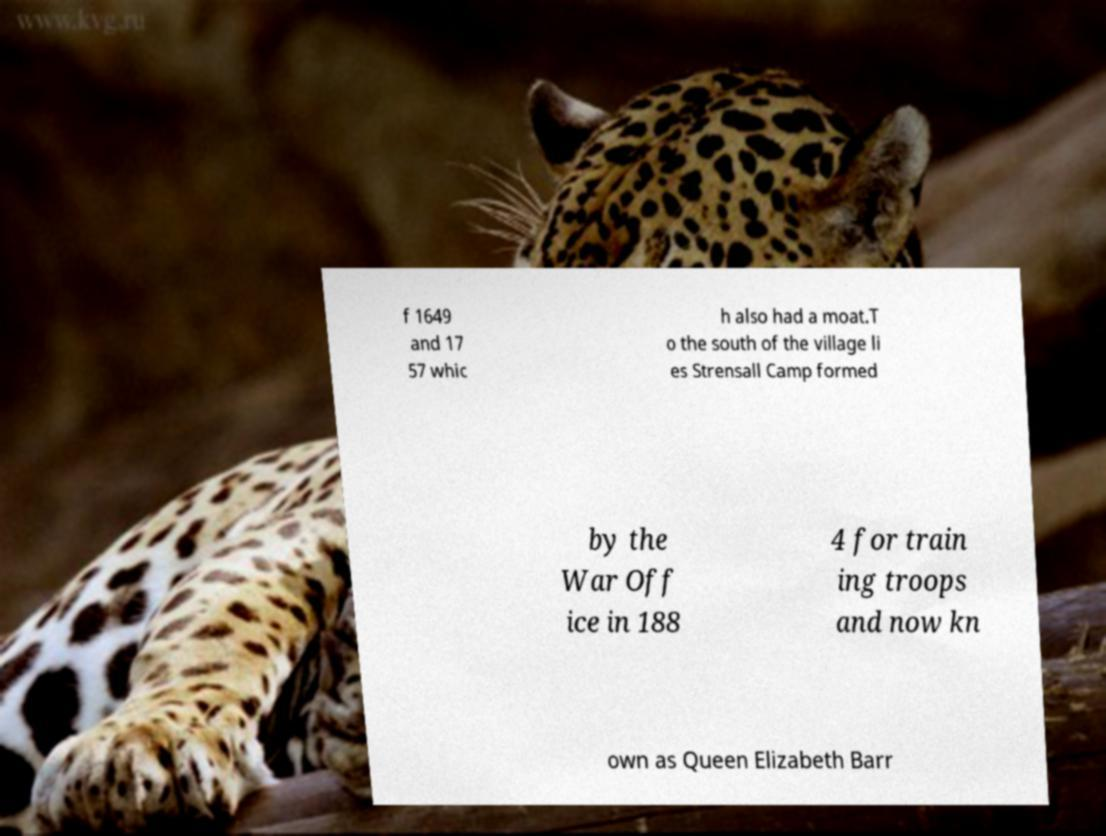Can you accurately transcribe the text from the provided image for me? f 1649 and 17 57 whic h also had a moat.T o the south of the village li es Strensall Camp formed by the War Off ice in 188 4 for train ing troops and now kn own as Queen Elizabeth Barr 